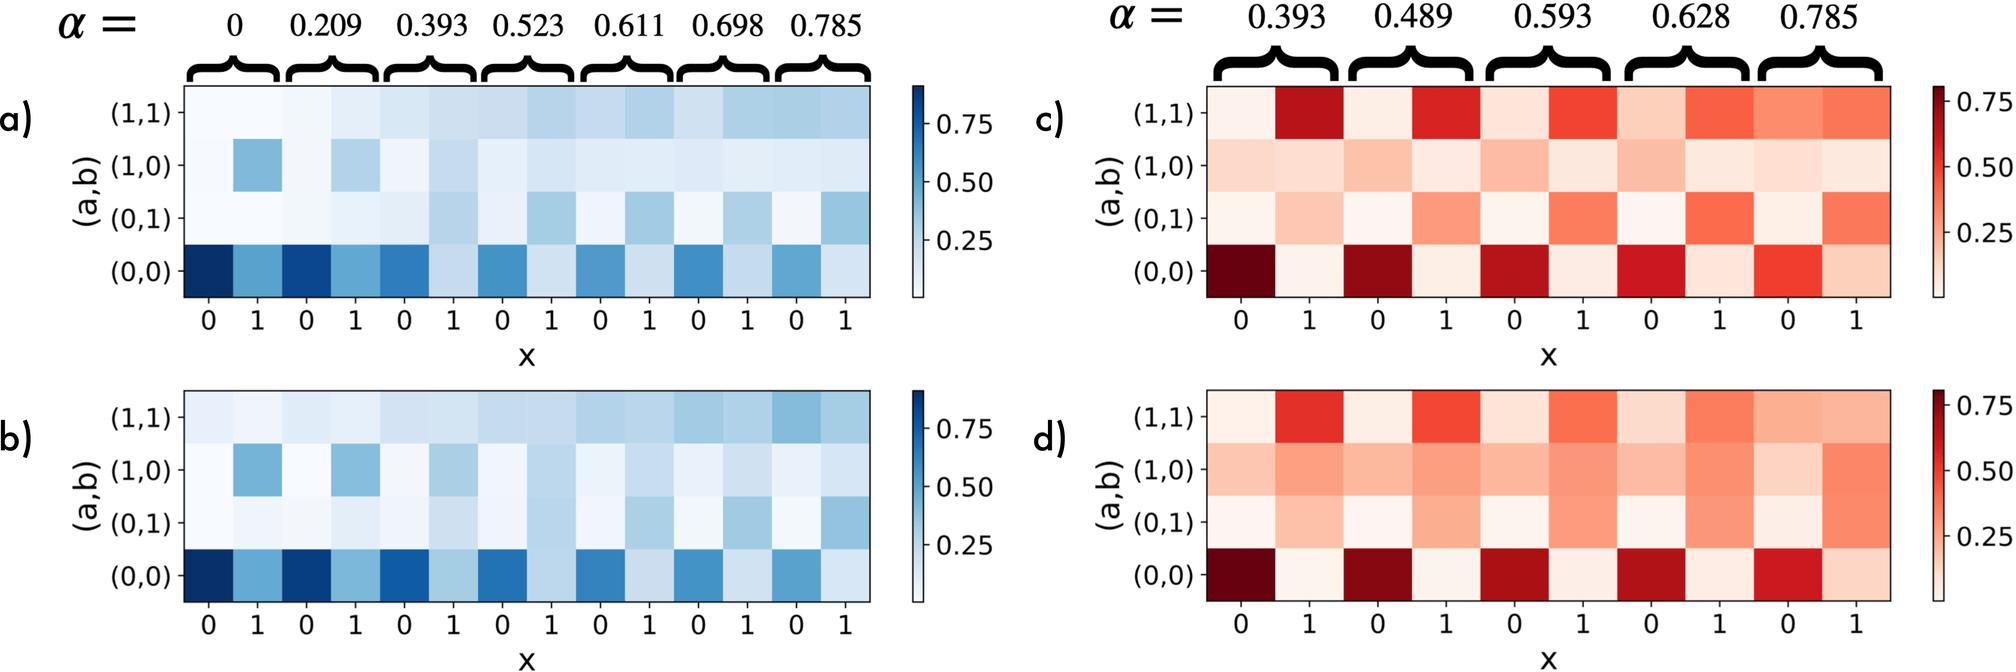What does the (0,1) and (1,0) mean in the context of these heatmaps? In the heatmaps, the labels such as (0,1) or (1,0) likely represent different conditions or variables being compared for correlation. For instance, in a study involving two variables, (1,0) might represent the scenario where the first condition is present and the second is absent, and vice versa for (0,1). These labels help in distinguishing between the different sets of correlations being analyzed across the conditions, enabling researchers to draw specific insights about how various scenarios influence the relationships being studied. 